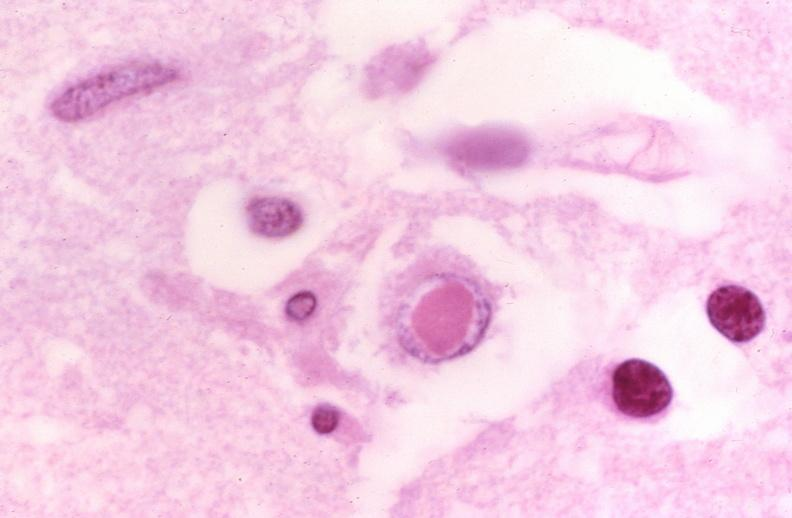s nervous present?
Answer the question using a single word or phrase. Yes 